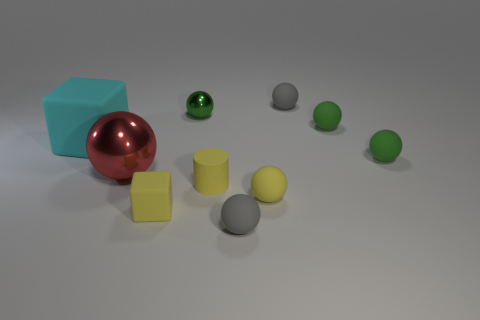Is the small yellow cylinder made of the same material as the tiny yellow thing on the left side of the green shiny ball?
Your response must be concise. Yes. There is a yellow matte thing that is the same shape as the green shiny thing; what is its size?
Make the answer very short. Small. Is the number of small green metallic things in front of the big block the same as the number of large matte objects to the left of the small yellow rubber cylinder?
Ensure brevity in your answer.  No. What number of other objects are there of the same material as the red ball?
Provide a short and direct response. 1. Are there the same number of small green rubber balls behind the yellow rubber cube and spheres?
Give a very brief answer. No. There is a red metal thing; is it the same size as the matte object left of the small yellow rubber block?
Your answer should be compact. Yes. The small gray rubber thing in front of the big red metallic thing has what shape?
Offer a very short reply. Sphere. Is there a big red rubber block?
Make the answer very short. No. There is a gray rubber sphere in front of the green metallic object; is it the same size as the green rubber sphere behind the cyan cube?
Provide a succinct answer. Yes. There is a sphere that is to the left of the matte cylinder and in front of the large block; what material is it made of?
Provide a succinct answer. Metal. 